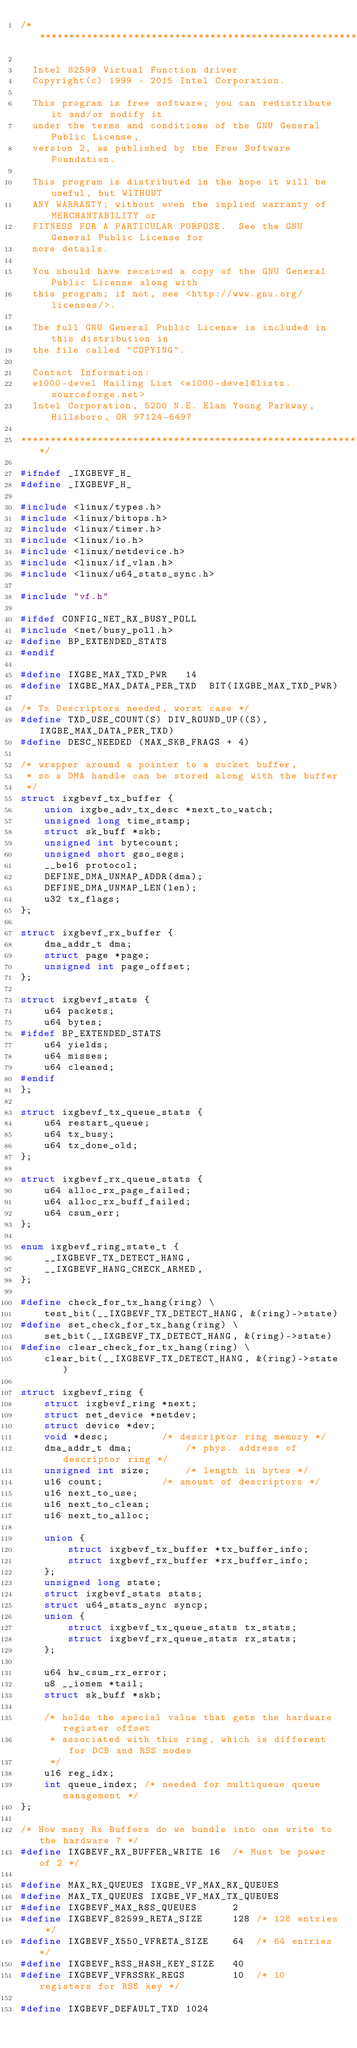<code> <loc_0><loc_0><loc_500><loc_500><_C_>/*******************************************************************************

  Intel 82599 Virtual Function driver
  Copyright(c) 1999 - 2015 Intel Corporation.

  This program is free software; you can redistribute it and/or modify it
  under the terms and conditions of the GNU General Public License,
  version 2, as published by the Free Software Foundation.

  This program is distributed in the hope it will be useful, but WITHOUT
  ANY WARRANTY; without even the implied warranty of MERCHANTABILITY or
  FITNESS FOR A PARTICULAR PURPOSE.  See the GNU General Public License for
  more details.

  You should have received a copy of the GNU General Public License along with
  this program; if not, see <http://www.gnu.org/licenses/>.

  The full GNU General Public License is included in this distribution in
  the file called "COPYING".

  Contact Information:
  e1000-devel Mailing List <e1000-devel@lists.sourceforge.net>
  Intel Corporation, 5200 N.E. Elam Young Parkway, Hillsboro, OR 97124-6497

*******************************************************************************/

#ifndef _IXGBEVF_H_
#define _IXGBEVF_H_

#include <linux/types.h>
#include <linux/bitops.h>
#include <linux/timer.h>
#include <linux/io.h>
#include <linux/netdevice.h>
#include <linux/if_vlan.h>
#include <linux/u64_stats_sync.h>

#include "vf.h"

#ifdef CONFIG_NET_RX_BUSY_POLL
#include <net/busy_poll.h>
#define BP_EXTENDED_STATS
#endif

#define IXGBE_MAX_TXD_PWR	14
#define IXGBE_MAX_DATA_PER_TXD	BIT(IXGBE_MAX_TXD_PWR)

/* Tx Descriptors needed, worst case */
#define TXD_USE_COUNT(S) DIV_ROUND_UP((S), IXGBE_MAX_DATA_PER_TXD)
#define DESC_NEEDED (MAX_SKB_FRAGS + 4)

/* wrapper around a pointer to a socket buffer,
 * so a DMA handle can be stored along with the buffer
 */
struct ixgbevf_tx_buffer {
	union ixgbe_adv_tx_desc *next_to_watch;
	unsigned long time_stamp;
	struct sk_buff *skb;
	unsigned int bytecount;
	unsigned short gso_segs;
	__be16 protocol;
	DEFINE_DMA_UNMAP_ADDR(dma);
	DEFINE_DMA_UNMAP_LEN(len);
	u32 tx_flags;
};

struct ixgbevf_rx_buffer {
	dma_addr_t dma;
	struct page *page;
	unsigned int page_offset;
};

struct ixgbevf_stats {
	u64 packets;
	u64 bytes;
#ifdef BP_EXTENDED_STATS
	u64 yields;
	u64 misses;
	u64 cleaned;
#endif
};

struct ixgbevf_tx_queue_stats {
	u64 restart_queue;
	u64 tx_busy;
	u64 tx_done_old;
};

struct ixgbevf_rx_queue_stats {
	u64 alloc_rx_page_failed;
	u64 alloc_rx_buff_failed;
	u64 csum_err;
};

enum ixgbevf_ring_state_t {
	__IXGBEVF_TX_DETECT_HANG,
	__IXGBEVF_HANG_CHECK_ARMED,
};

#define check_for_tx_hang(ring) \
	test_bit(__IXGBEVF_TX_DETECT_HANG, &(ring)->state)
#define set_check_for_tx_hang(ring) \
	set_bit(__IXGBEVF_TX_DETECT_HANG, &(ring)->state)
#define clear_check_for_tx_hang(ring) \
	clear_bit(__IXGBEVF_TX_DETECT_HANG, &(ring)->state)

struct ixgbevf_ring {
	struct ixgbevf_ring *next;
	struct net_device *netdev;
	struct device *dev;
	void *desc;			/* descriptor ring memory */
	dma_addr_t dma;			/* phys. address of descriptor ring */
	unsigned int size;		/* length in bytes */
	u16 count;			/* amount of descriptors */
	u16 next_to_use;
	u16 next_to_clean;
	u16 next_to_alloc;

	union {
		struct ixgbevf_tx_buffer *tx_buffer_info;
		struct ixgbevf_rx_buffer *rx_buffer_info;
	};
	unsigned long state;
	struct ixgbevf_stats stats;
	struct u64_stats_sync syncp;
	union {
		struct ixgbevf_tx_queue_stats tx_stats;
		struct ixgbevf_rx_queue_stats rx_stats;
	};

	u64 hw_csum_rx_error;
	u8 __iomem *tail;
	struct sk_buff *skb;

	/* holds the special value that gets the hardware register offset
	 * associated with this ring, which is different for DCB and RSS modes
	 */
	u16 reg_idx;
	int queue_index; /* needed for multiqueue queue management */
};

/* How many Rx Buffers do we bundle into one write to the hardware ? */
#define IXGBEVF_RX_BUFFER_WRITE	16	/* Must be power of 2 */

#define MAX_RX_QUEUES IXGBE_VF_MAX_RX_QUEUES
#define MAX_TX_QUEUES IXGBE_VF_MAX_TX_QUEUES
#define IXGBEVF_MAX_RSS_QUEUES		2
#define IXGBEVF_82599_RETA_SIZE		128	/* 128 entries */
#define IXGBEVF_X550_VFRETA_SIZE	64	/* 64 entries */
#define IXGBEVF_RSS_HASH_KEY_SIZE	40
#define IXGBEVF_VFRSSRK_REGS		10	/* 10 registers for RSS key */

#define IXGBEVF_DEFAULT_TXD	1024</code> 